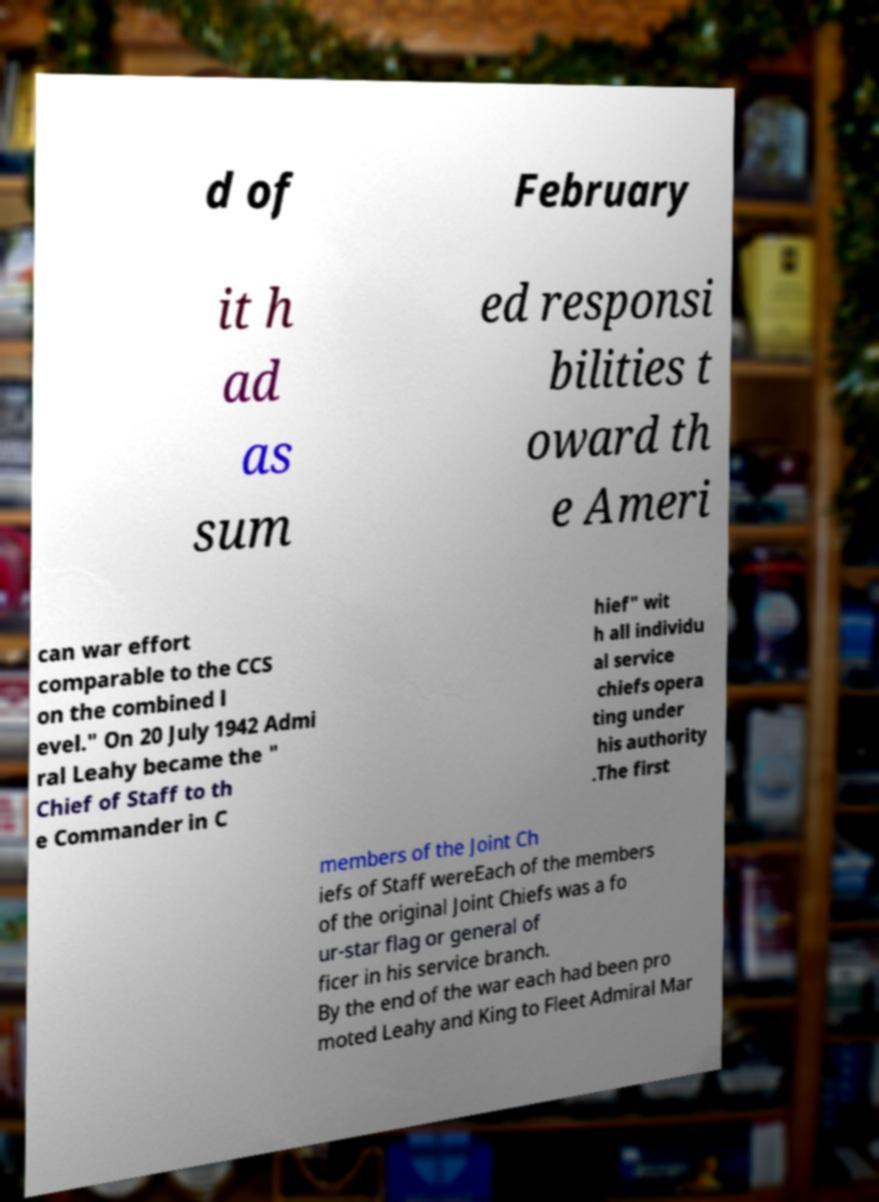Please identify and transcribe the text found in this image. d of February it h ad as sum ed responsi bilities t oward th e Ameri can war effort comparable to the CCS on the combined l evel." On 20 July 1942 Admi ral Leahy became the " Chief of Staff to th e Commander in C hief" wit h all individu al service chiefs opera ting under his authority .The first members of the Joint Ch iefs of Staff wereEach of the members of the original Joint Chiefs was a fo ur-star flag or general of ficer in his service branch. By the end of the war each had been pro moted Leahy and King to Fleet Admiral Mar 